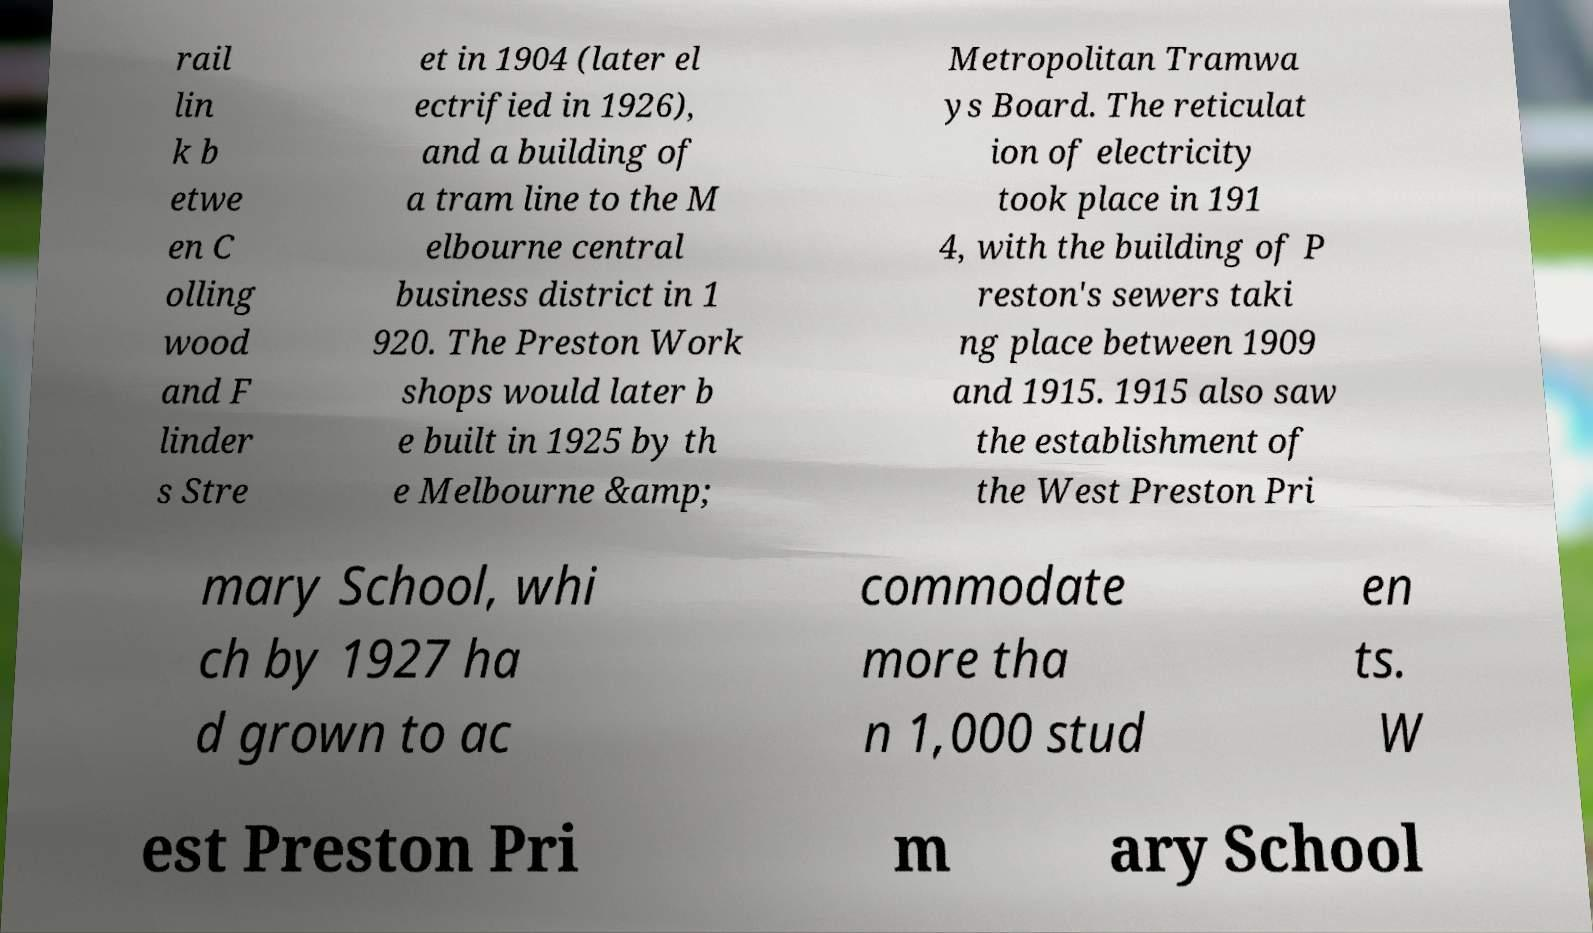What messages or text are displayed in this image? I need them in a readable, typed format. rail lin k b etwe en C olling wood and F linder s Stre et in 1904 (later el ectrified in 1926), and a building of a tram line to the M elbourne central business district in 1 920. The Preston Work shops would later b e built in 1925 by th e Melbourne &amp; Metropolitan Tramwa ys Board. The reticulat ion of electricity took place in 191 4, with the building of P reston's sewers taki ng place between 1909 and 1915. 1915 also saw the establishment of the West Preston Pri mary School, whi ch by 1927 ha d grown to ac commodate more tha n 1,000 stud en ts. W est Preston Pri m ary School 